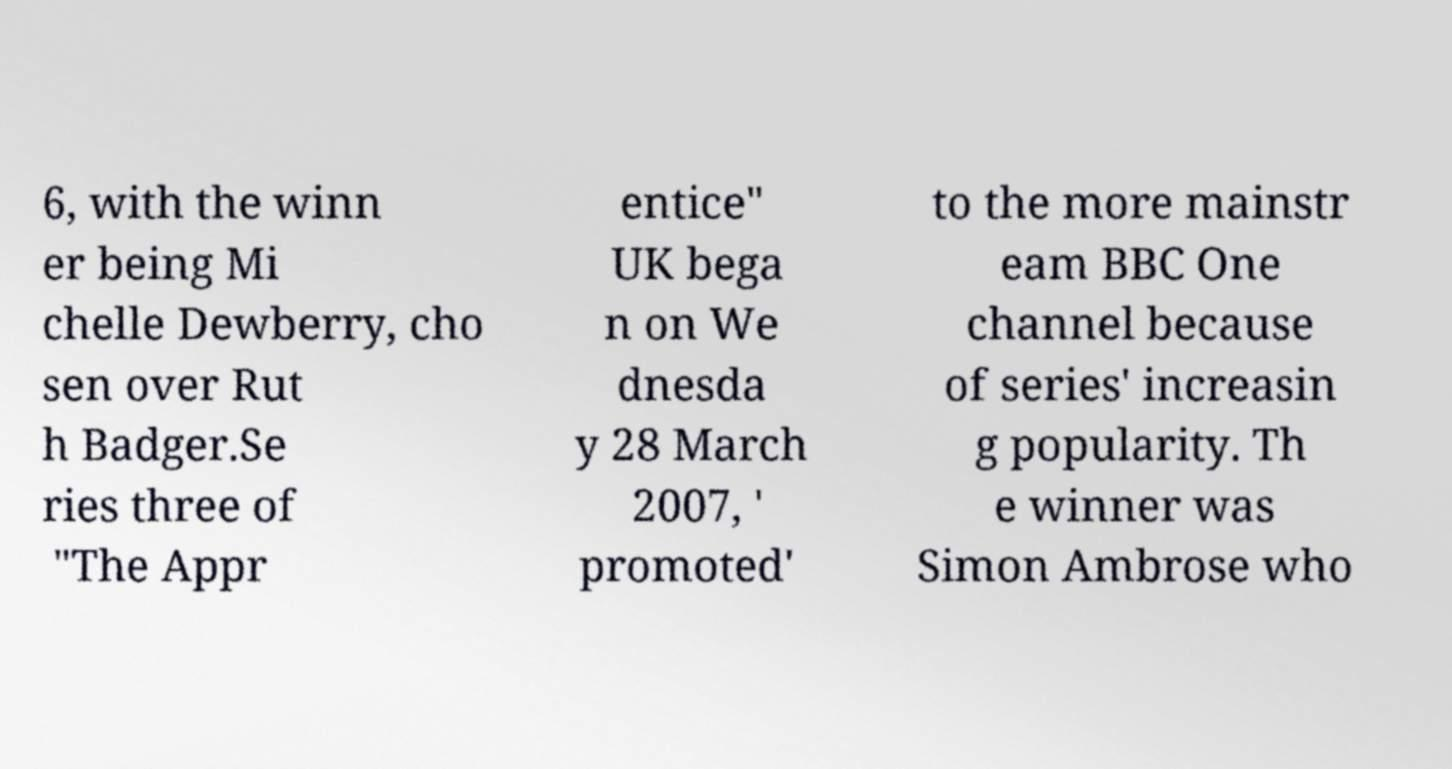There's text embedded in this image that I need extracted. Can you transcribe it verbatim? 6, with the winn er being Mi chelle Dewberry, cho sen over Rut h Badger.Se ries three of "The Appr entice" UK bega n on We dnesda y 28 March 2007, ' promoted' to the more mainstr eam BBC One channel because of series' increasin g popularity. Th e winner was Simon Ambrose who 